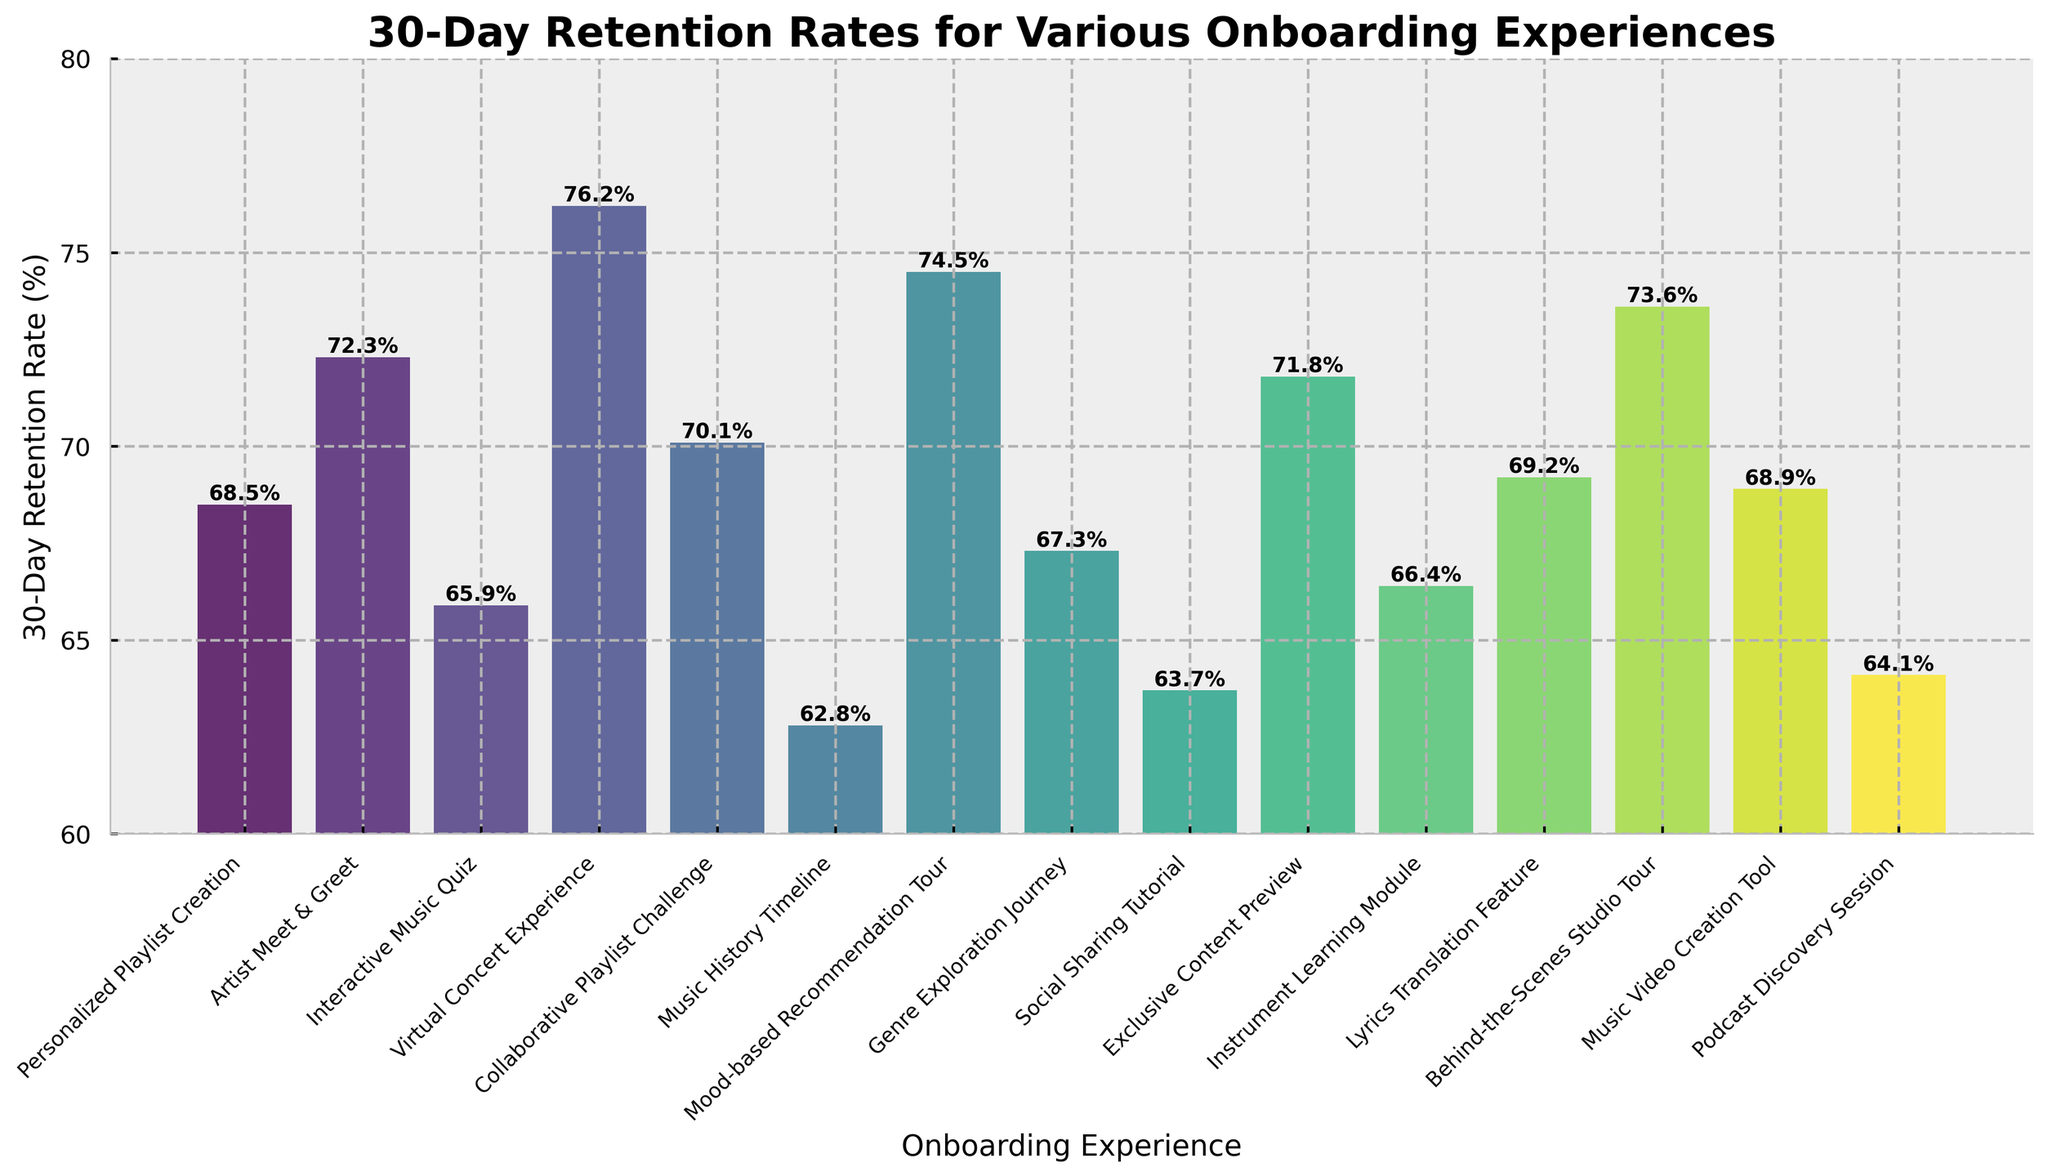what's the average 30-day retention rate for all onboarding experiences? To find the average, sum all the retention rates and divide by the number of experiences. The sum is 68.5 + 72.3 + 65.9 + 76.2 + 70.1 + 62.8 + 74.5 + 67.3 + 63.7 + 71.8 + 66.4 + 69.2 + 73.6 + 68.9 + 64.1 = 995.3. There are 15 experiences. So, the average retention rate is 995.3 / 15 = 66.35
Answer: 66.4 Which onboarding experience has the highest retention rate? Locate the tallest bar in the figure, which corresponds to the highest retention rate. The highest bar indicates the "Virtual Concert Experience" with a retention rate of 76.2%
Answer: Virtual Concert Experience What's the total retention rate for "Personalized Playlist Creation" and "Behind-the-Scenes Studio Tour"? Add the retention rates of both experiences. For "Personalized Playlist Creation" it is 68.5%, and for "Behind-the-Scenes Studio Tour" it is 73.6%. The total retention rate is 68.5 + 73.6 = 142.1%
Answer: 142.1 Which has a greater retention rate: "Mood-based Recommendation Tour" or "Exclusive Content Preview"? Compare the heights of the bars for "Mood-based Recommendation Tour" (74.5%) and "Exclusive Content Preview" (71.8%). The "Mood-based Recommendation Tour" has a greater retention rate.
Answer: Mood-based Recommendation Tour How many onboarding experiences have a retention rate below 65%? Count the bars with heights representing a retention rate below 65%. These experiences are "Music History Timeline" (62.8%) and "Social Sharing Tutorial" (63.7%), totaling 2 experiences.
Answer: 2 What is the difference in retention rate between "Artist Meet & Greet" and "Collaborative Playlist Challenge"? Subtract the retention rate of "Collaborative Playlist Challenge" (70.1%) from "Artist Meet & Greet" (72.3%). The difference is 72.3 - 70.1 = 2.2%
Answer: 2.2 Which onboarding experience has a lower retention rate: "Interactive Music Quiz" or "Podcast Discovery Session"? Compare the retention rates of "Interactive Music Quiz" (65.9%) and "Podcast Discovery Session" (64.1%), and note the lower value. "Podcast Discovery Session" has the lower retention rate.
Answer: Podcast Discovery Session What's the median retention rate of all onboarding experiences? To find the median, list all retention rates in ascending order and locate the middle value. Ordered rates: 62.8, 63.7, 64.1, 65.9, 66.4, 67.3, 68.5, 68.9, 69.2, 70.1, 71.8, 72.3, 73.6, 74.5, 76.2. The middle value (8th in this list) is 68.9.
Answer: 68.9 Which onboarding experiences have retention rates exactly between 65% and 70%? Identify bars with heights between 65% and 70%. These experiences are "Interactive Music Quiz" (65.9%), "Genre Exploration Journey" (67.3%), "Personalized Playlist Creation" (68.5%), "Music Video Creation Tool" (68.9%), and "Lyrics Translation Feature" (69.2%).
Answer: Interactive Music Quiz, Genre Exploration Journey, Personalized Playlist Creation, Music Video Creation Tool, Lyrics Translation Feature 